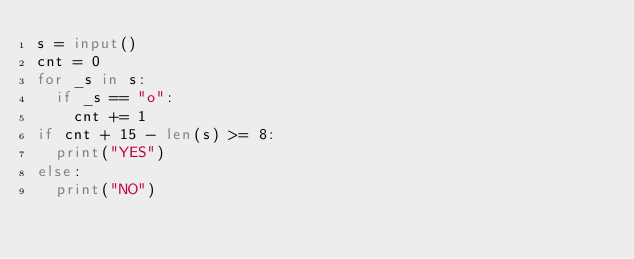Convert code to text. <code><loc_0><loc_0><loc_500><loc_500><_Python_>s = input()
cnt = 0
for _s in s:
  if _s == "o":
    cnt += 1
if cnt + 15 - len(s) >= 8:
  print("YES")
else:
  print("NO")</code> 